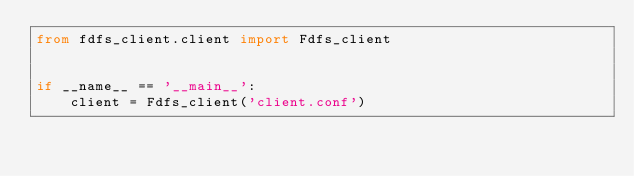Convert code to text. <code><loc_0><loc_0><loc_500><loc_500><_Python_>from fdfs_client.client import Fdfs_client


if __name__ == '__main__':
    client = Fdfs_client('client.conf')</code> 